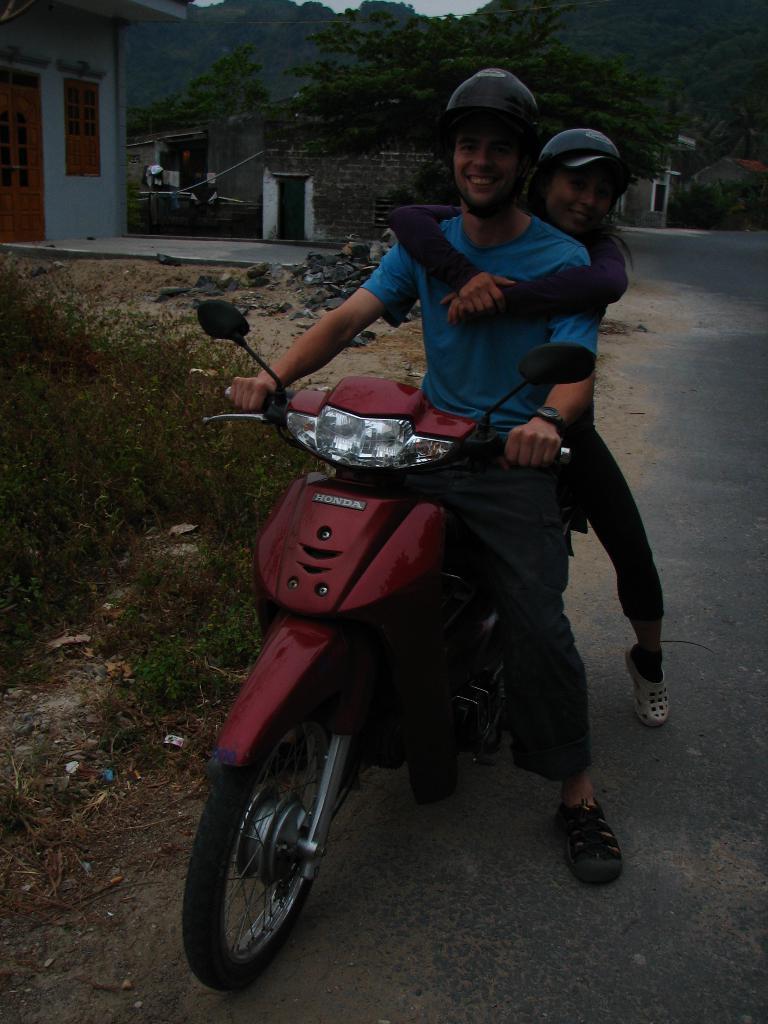Could you give a brief overview of what you see in this image? In this picture we can see a man and a lady on the vehicle and behind them there are some plants,trees, house and stones and some grass on the floor. 